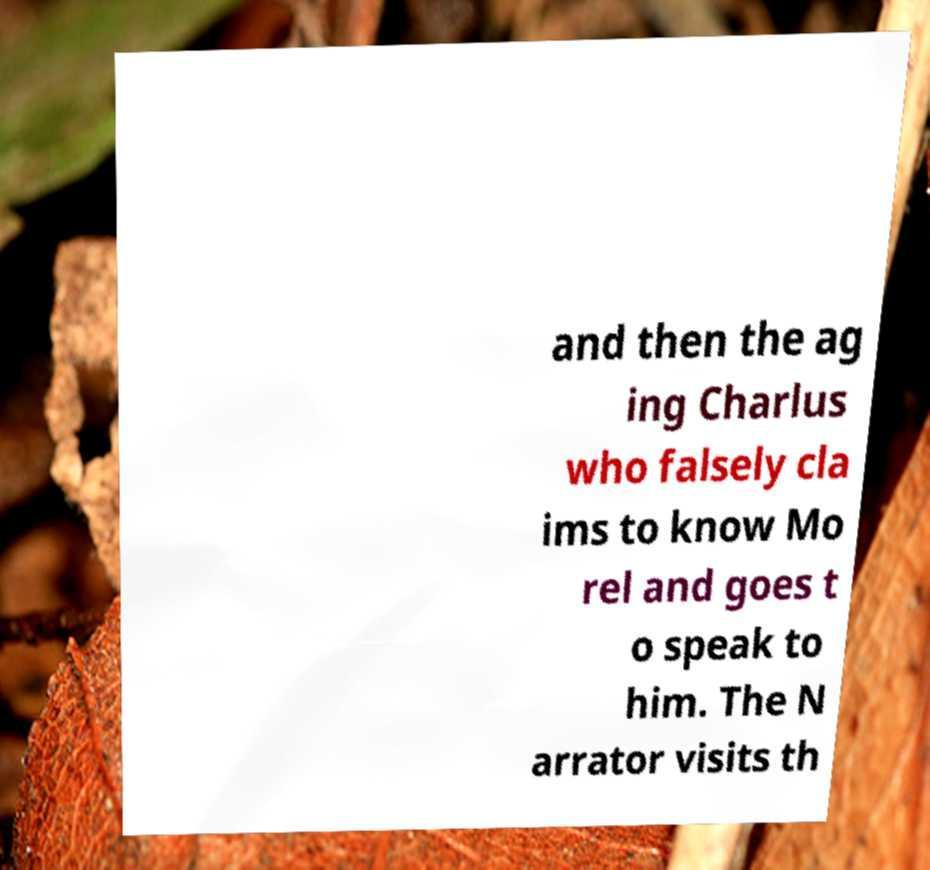Please read and relay the text visible in this image. What does it say? and then the ag ing Charlus who falsely cla ims to know Mo rel and goes t o speak to him. The N arrator visits th 